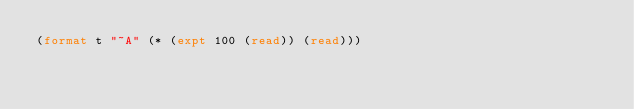<code> <loc_0><loc_0><loc_500><loc_500><_Lisp_>(format t "~A" (* (expt 100 (read)) (read)))</code> 